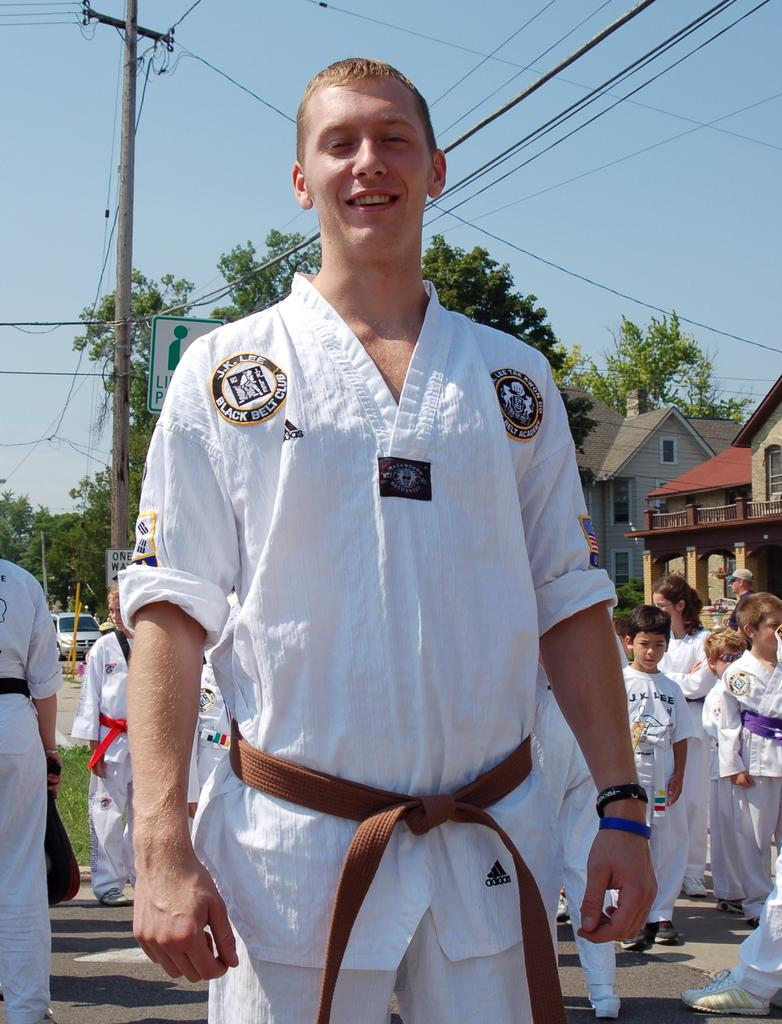<image>
Summarize the visual content of the image. the word black is on the shirt of the person 